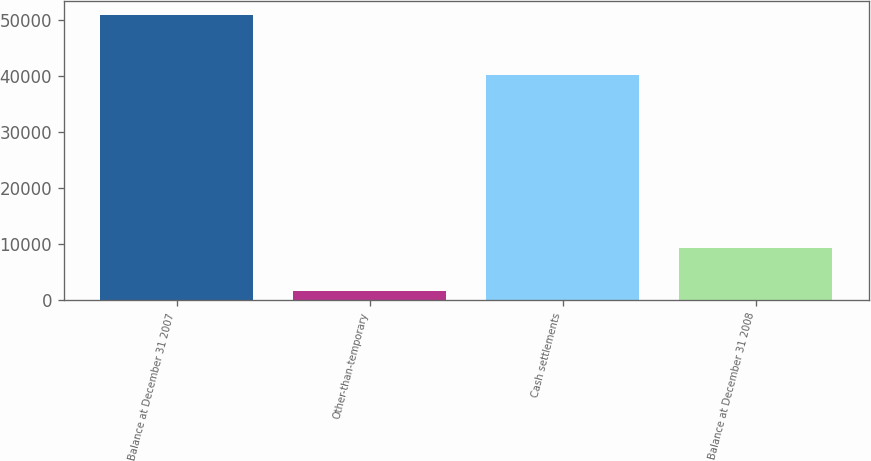<chart> <loc_0><loc_0><loc_500><loc_500><bar_chart><fcel>Balance at December 31 2007<fcel>Other-than-temporary<fcel>Cash settlements<fcel>Balance at December 31 2008<nl><fcel>50940<fcel>1527<fcel>40163<fcel>9250<nl></chart> 